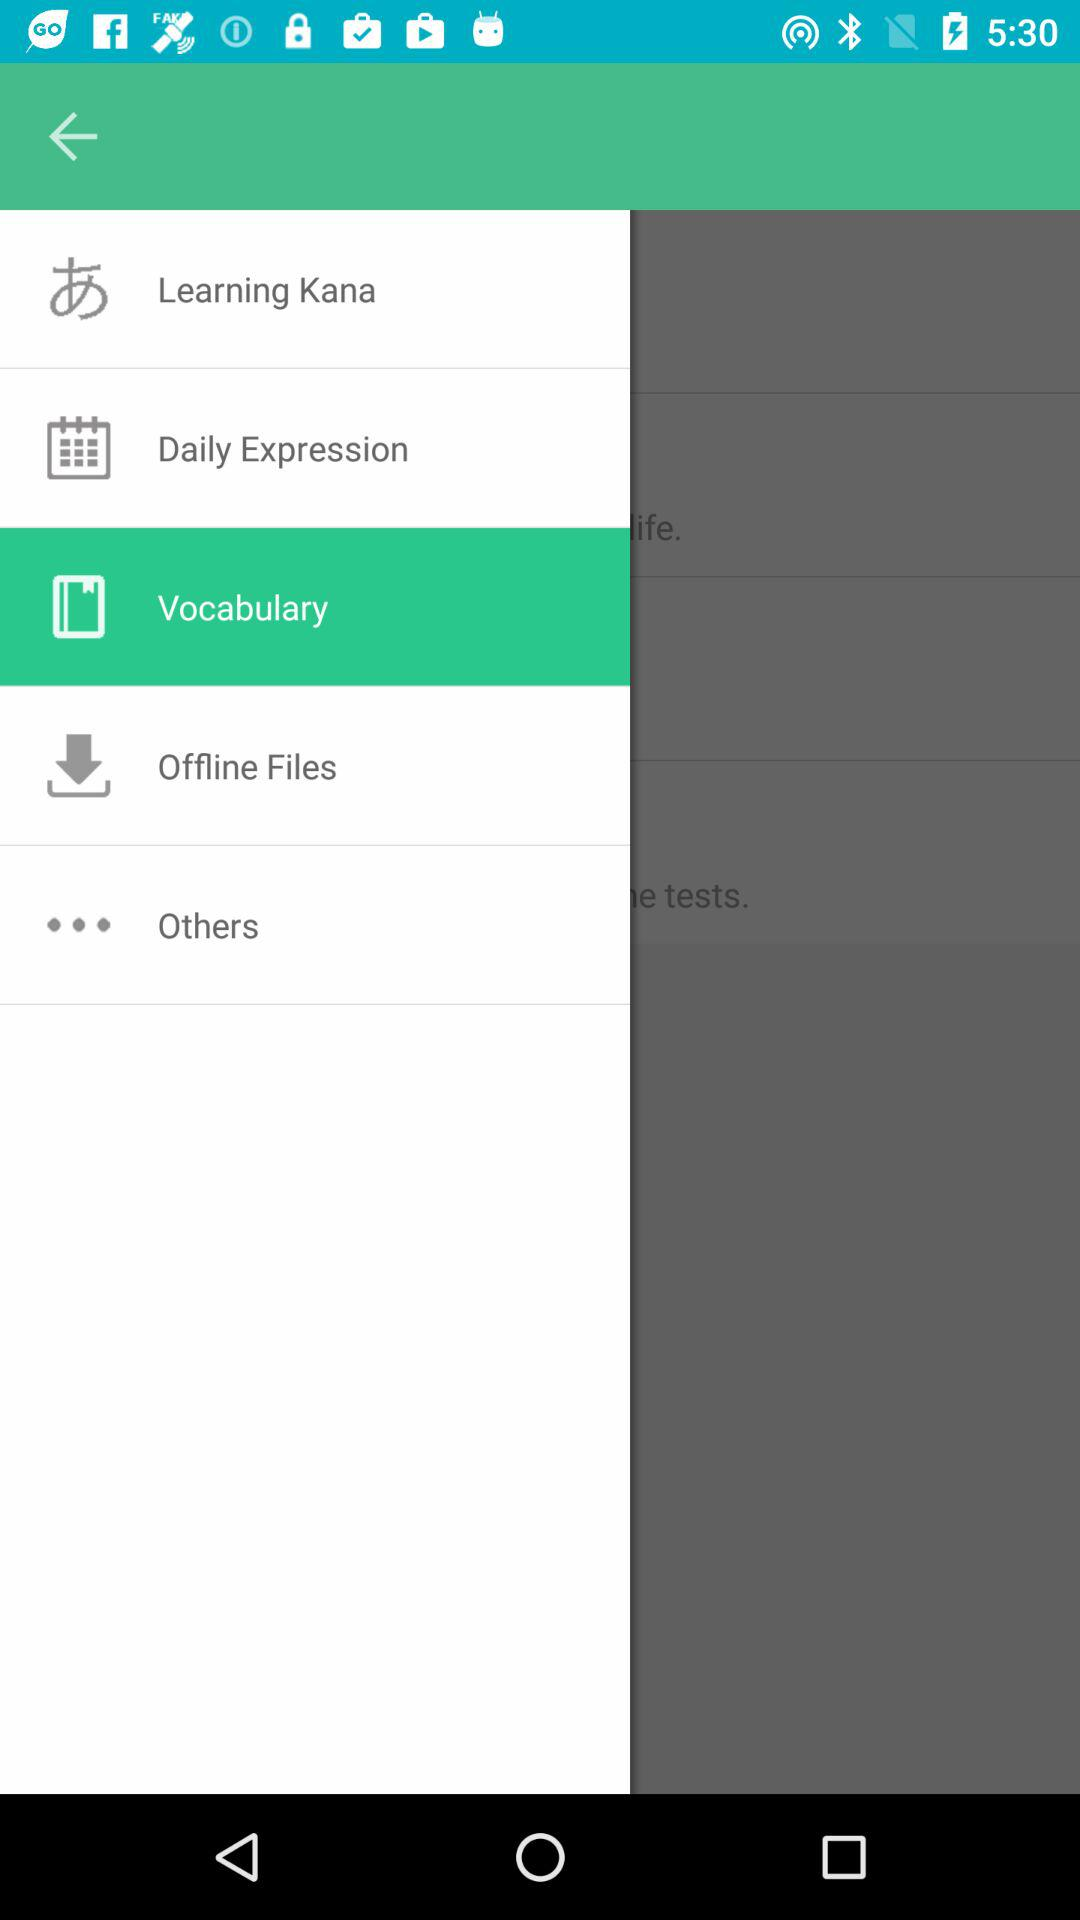What is the selected item in the menu? The selected item in the menu is "Vocabulary". 